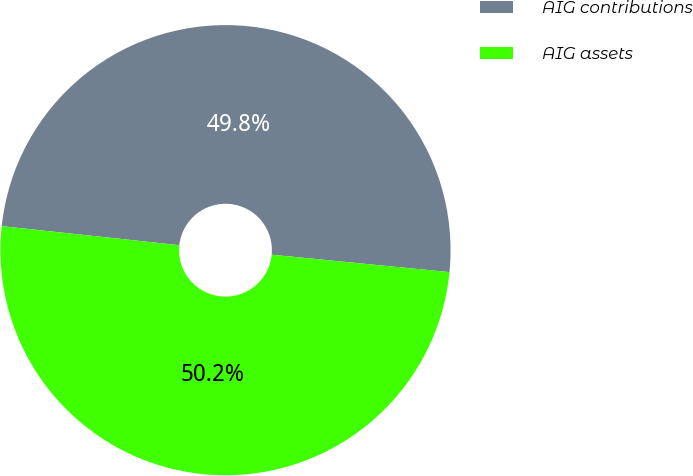Convert chart. <chart><loc_0><loc_0><loc_500><loc_500><pie_chart><fcel>AIG contributions<fcel>AIG assets<nl><fcel>49.85%<fcel>50.15%<nl></chart> 